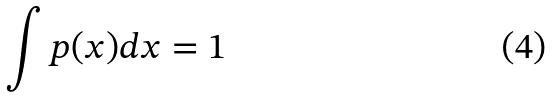Convert formula to latex. <formula><loc_0><loc_0><loc_500><loc_500>\int p ( x ) d x = 1</formula> 